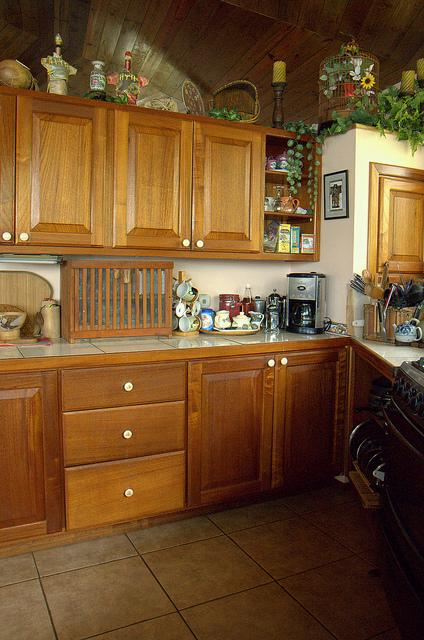How many drawers are in the bottom cabinet of this kitchen? three 